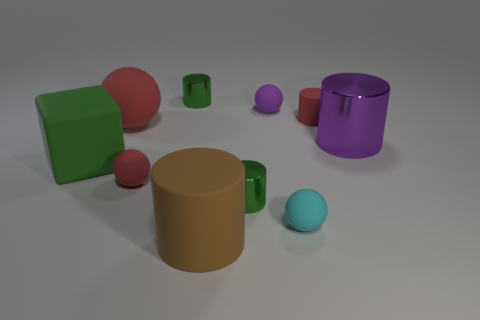What is the material of the small cylinder that is the same color as the big ball?
Your answer should be very brief. Rubber. What number of other things are there of the same color as the large metallic object?
Provide a succinct answer. 1. Is there any other thing that has the same shape as the tiny purple object?
Give a very brief answer. Yes. There is a small cylinder that is both to the left of the purple matte object and behind the purple shiny thing; what color is it?
Your answer should be compact. Green. What number of spheres are brown objects or matte things?
Keep it short and to the point. 4. How many cyan cylinders have the same size as the red rubber cylinder?
Make the answer very short. 0. There is a small rubber thing to the right of the cyan matte object; what number of metal cylinders are to the right of it?
Your response must be concise. 1. There is a metal object that is both left of the purple metal cylinder and behind the rubber cube; what is its size?
Provide a succinct answer. Small. Is the number of large brown matte cylinders greater than the number of tiny gray metal things?
Your response must be concise. Yes. Are there any other matte cylinders that have the same color as the tiny rubber cylinder?
Provide a short and direct response. No. 